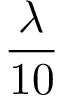<formula> <loc_0><loc_0><loc_500><loc_500>\frac { \lambda } { 1 0 }</formula> 